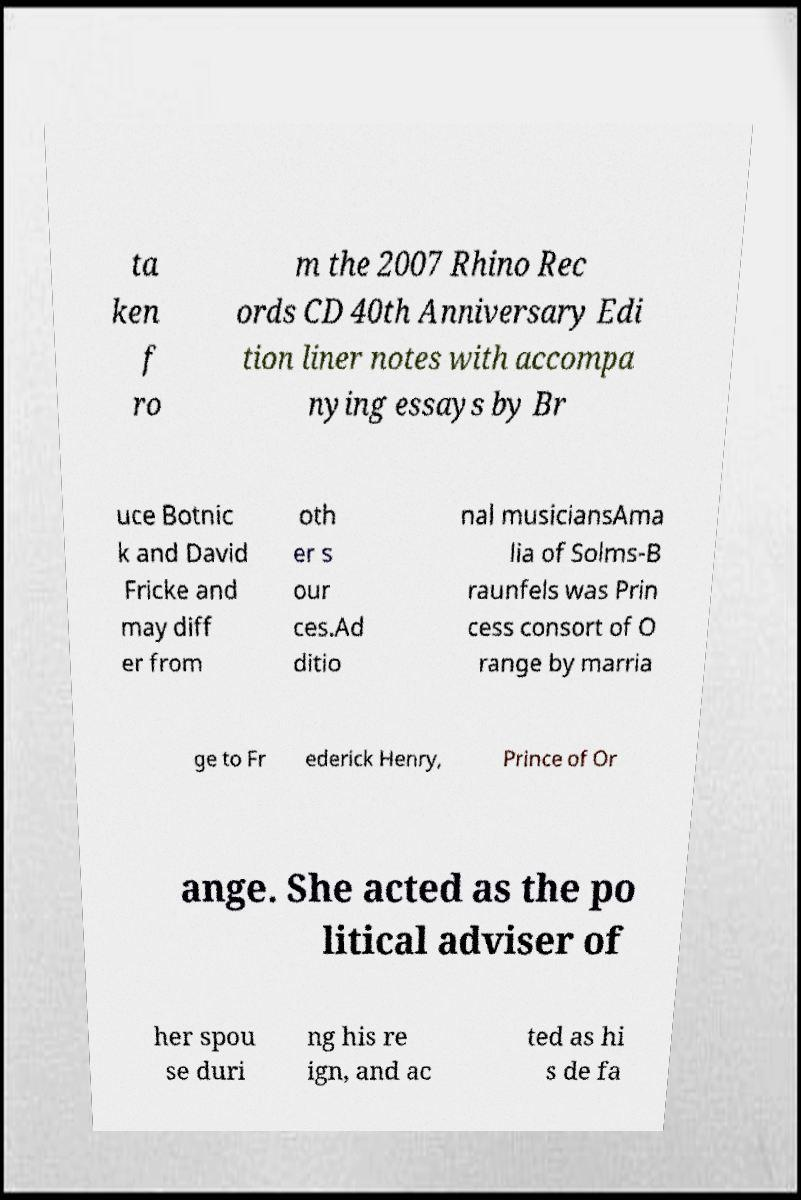Please identify and transcribe the text found in this image. ta ken f ro m the 2007 Rhino Rec ords CD 40th Anniversary Edi tion liner notes with accompa nying essays by Br uce Botnic k and David Fricke and may diff er from oth er s our ces.Ad ditio nal musiciansAma lia of Solms-B raunfels was Prin cess consort of O range by marria ge to Fr ederick Henry, Prince of Or ange. She acted as the po litical adviser of her spou se duri ng his re ign, and ac ted as hi s de fa 